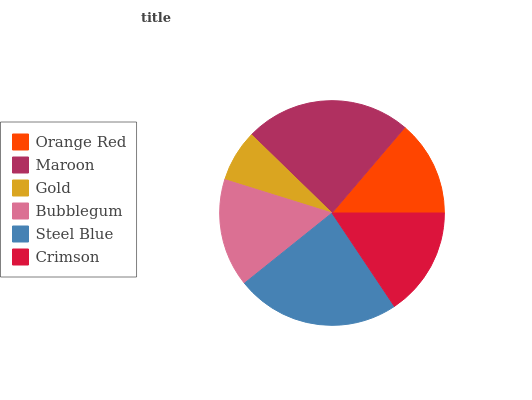Is Gold the minimum?
Answer yes or no. Yes. Is Maroon the maximum?
Answer yes or no. Yes. Is Maroon the minimum?
Answer yes or no. No. Is Gold the maximum?
Answer yes or no. No. Is Maroon greater than Gold?
Answer yes or no. Yes. Is Gold less than Maroon?
Answer yes or no. Yes. Is Gold greater than Maroon?
Answer yes or no. No. Is Maroon less than Gold?
Answer yes or no. No. Is Crimson the high median?
Answer yes or no. Yes. Is Bubblegum the low median?
Answer yes or no. Yes. Is Steel Blue the high median?
Answer yes or no. No. Is Crimson the low median?
Answer yes or no. No. 